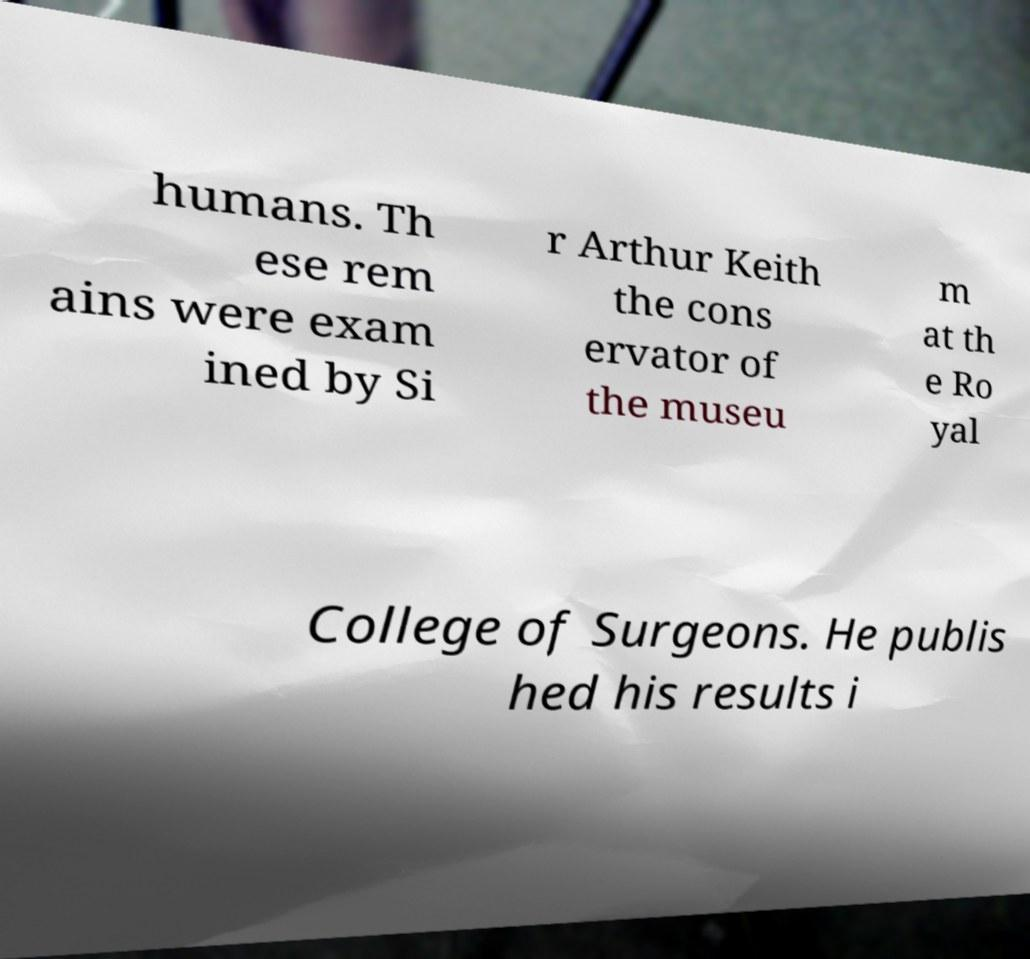Could you extract and type out the text from this image? humans. Th ese rem ains were exam ined by Si r Arthur Keith the cons ervator of the museu m at th e Ro yal College of Surgeons. He publis hed his results i 